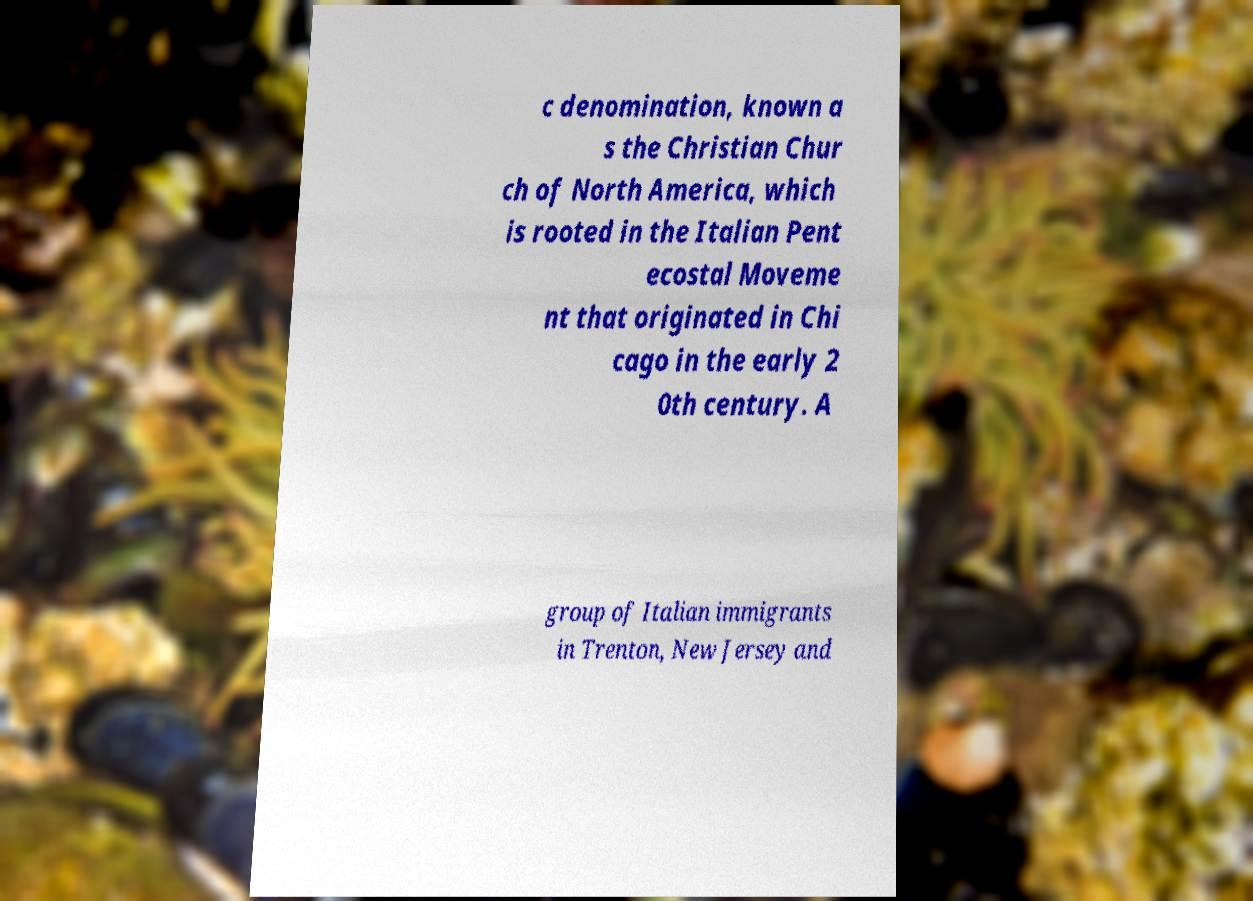Can you read and provide the text displayed in the image?This photo seems to have some interesting text. Can you extract and type it out for me? c denomination, known a s the Christian Chur ch of North America, which is rooted in the Italian Pent ecostal Moveme nt that originated in Chi cago in the early 2 0th century. A group of Italian immigrants in Trenton, New Jersey and 